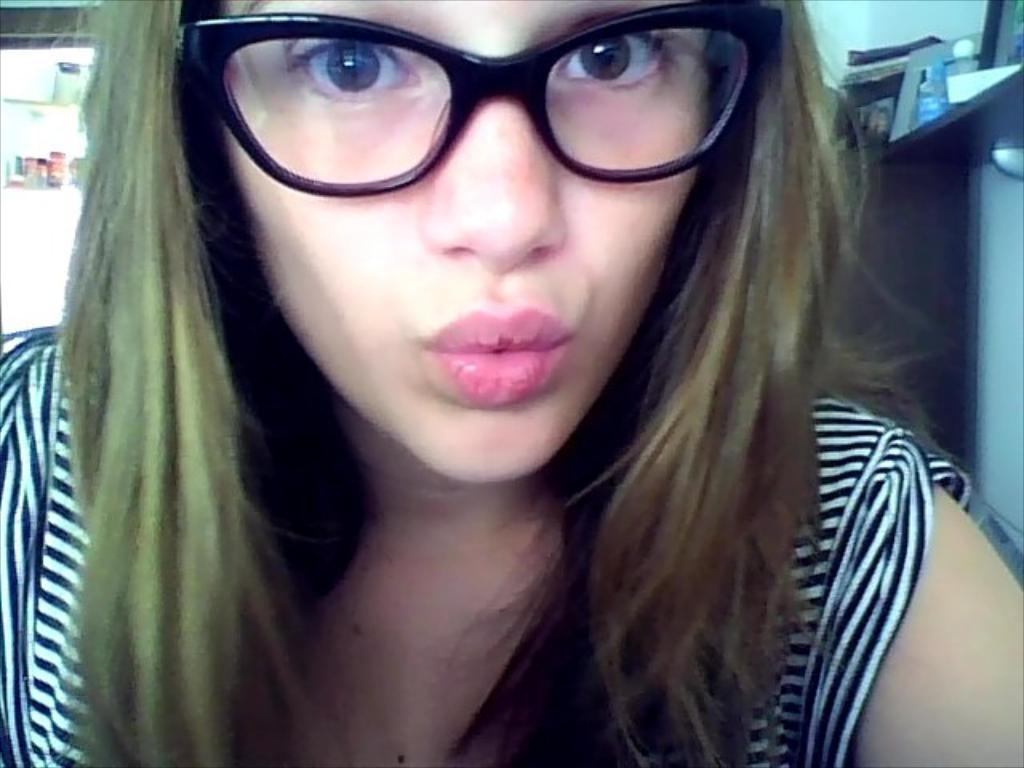What is the main subject of the image? The main subject of the image is a woman. Can you describe the woman's appearance in the image? The woman is wearing spectacles in the image. What type of salt can be seen on the woman's face in the image? There is no salt present on the woman's face in the image. 